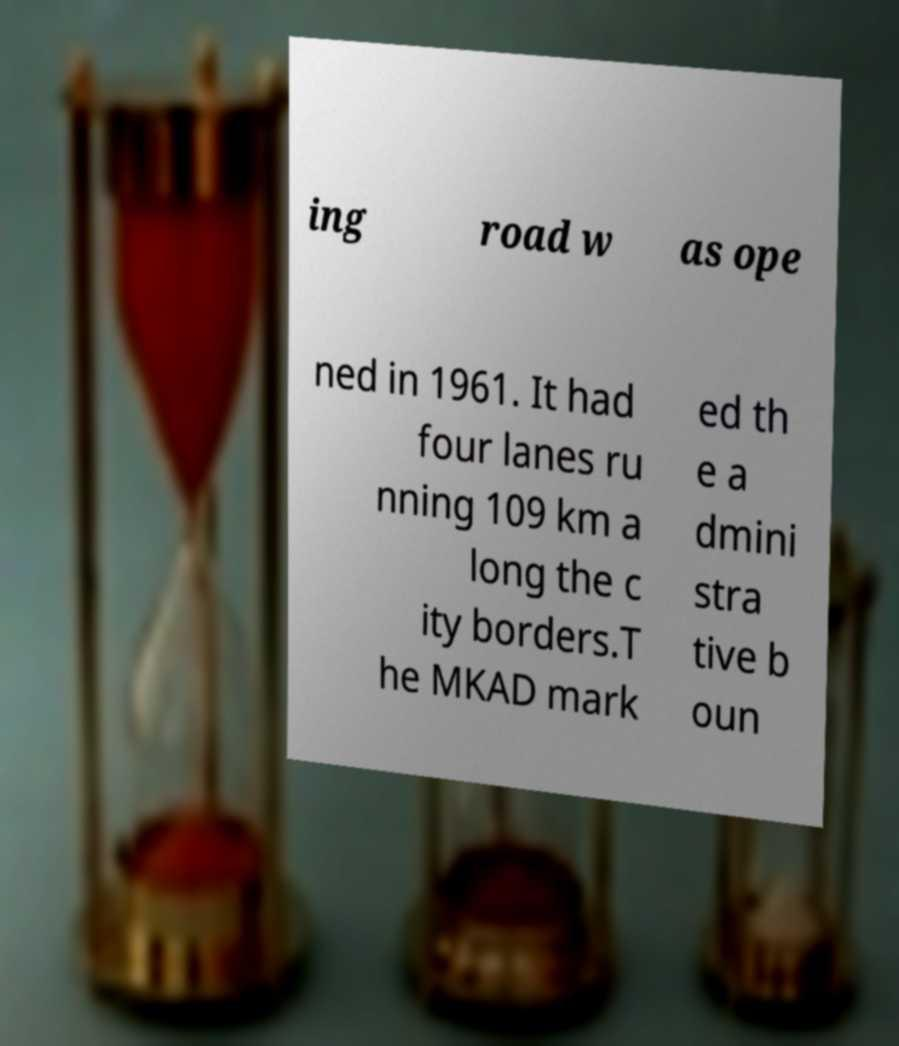For documentation purposes, I need the text within this image transcribed. Could you provide that? ing road w as ope ned in 1961. It had four lanes ru nning 109 km a long the c ity borders.T he MKAD mark ed th e a dmini stra tive b oun 